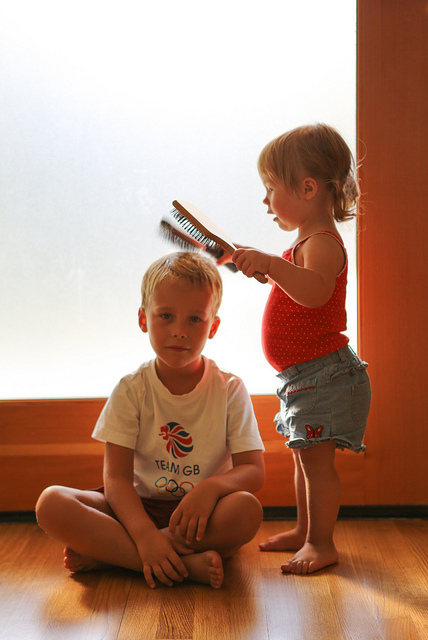Read and extract the text from this image. TEAM GB 